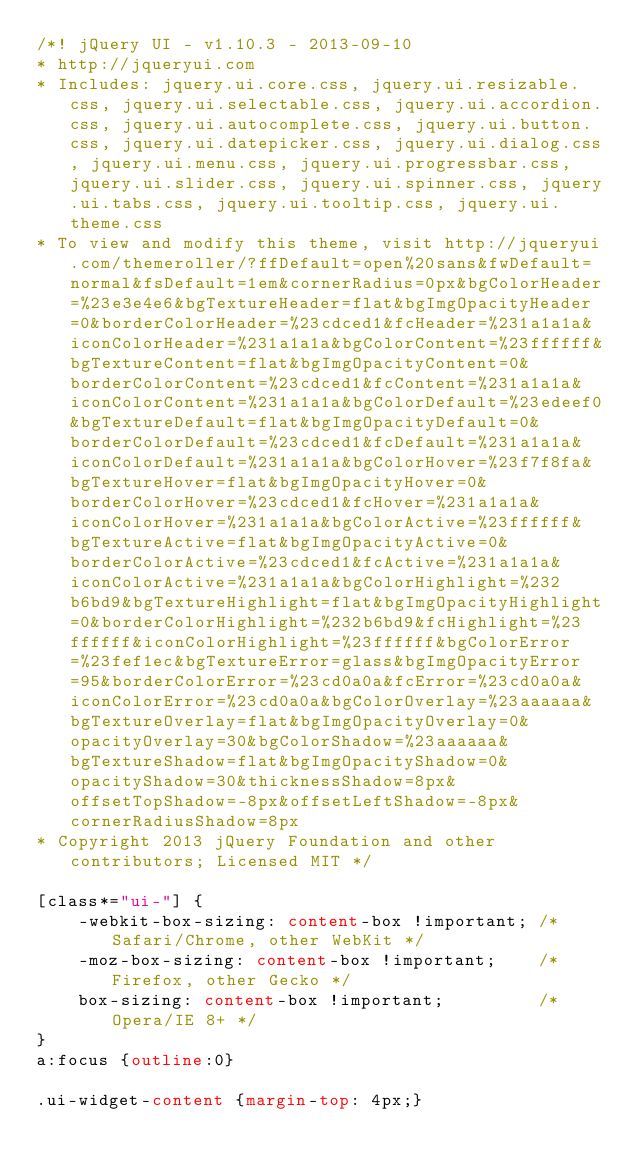Convert code to text. <code><loc_0><loc_0><loc_500><loc_500><_CSS_>/*! jQuery UI - v1.10.3 - 2013-09-10
* http://jqueryui.com
* Includes: jquery.ui.core.css, jquery.ui.resizable.css, jquery.ui.selectable.css, jquery.ui.accordion.css, jquery.ui.autocomplete.css, jquery.ui.button.css, jquery.ui.datepicker.css, jquery.ui.dialog.css, jquery.ui.menu.css, jquery.ui.progressbar.css, jquery.ui.slider.css, jquery.ui.spinner.css, jquery.ui.tabs.css, jquery.ui.tooltip.css, jquery.ui.theme.css
* To view and modify this theme, visit http://jqueryui.com/themeroller/?ffDefault=open%20sans&fwDefault=normal&fsDefault=1em&cornerRadius=0px&bgColorHeader=%23e3e4e6&bgTextureHeader=flat&bgImgOpacityHeader=0&borderColorHeader=%23cdced1&fcHeader=%231a1a1a&iconColorHeader=%231a1a1a&bgColorContent=%23ffffff&bgTextureContent=flat&bgImgOpacityContent=0&borderColorContent=%23cdced1&fcContent=%231a1a1a&iconColorContent=%231a1a1a&bgColorDefault=%23edeef0&bgTextureDefault=flat&bgImgOpacityDefault=0&borderColorDefault=%23cdced1&fcDefault=%231a1a1a&iconColorDefault=%231a1a1a&bgColorHover=%23f7f8fa&bgTextureHover=flat&bgImgOpacityHover=0&borderColorHover=%23cdced1&fcHover=%231a1a1a&iconColorHover=%231a1a1a&bgColorActive=%23ffffff&bgTextureActive=flat&bgImgOpacityActive=0&borderColorActive=%23cdced1&fcActive=%231a1a1a&iconColorActive=%231a1a1a&bgColorHighlight=%232b6bd9&bgTextureHighlight=flat&bgImgOpacityHighlight=0&borderColorHighlight=%232b6bd9&fcHighlight=%23ffffff&iconColorHighlight=%23ffffff&bgColorError=%23fef1ec&bgTextureError=glass&bgImgOpacityError=95&borderColorError=%23cd0a0a&fcError=%23cd0a0a&iconColorError=%23cd0a0a&bgColorOverlay=%23aaaaaa&bgTextureOverlay=flat&bgImgOpacityOverlay=0&opacityOverlay=30&bgColorShadow=%23aaaaaa&bgTextureShadow=flat&bgImgOpacityShadow=0&opacityShadow=30&thicknessShadow=8px&offsetTopShadow=-8px&offsetLeftShadow=-8px&cornerRadiusShadow=8px
* Copyright 2013 jQuery Foundation and other contributors; Licensed MIT */

[class*="ui-"] {
	-webkit-box-sizing: content-box !important; /* Safari/Chrome, other WebKit */
	-moz-box-sizing: content-box !important;    /* Firefox, other Gecko */
	box-sizing: content-box !important;         /* Opera/IE 8+ */
}
a:focus {outline:0}

.ui-widget-content {margin-top: 4px;}
</code> 